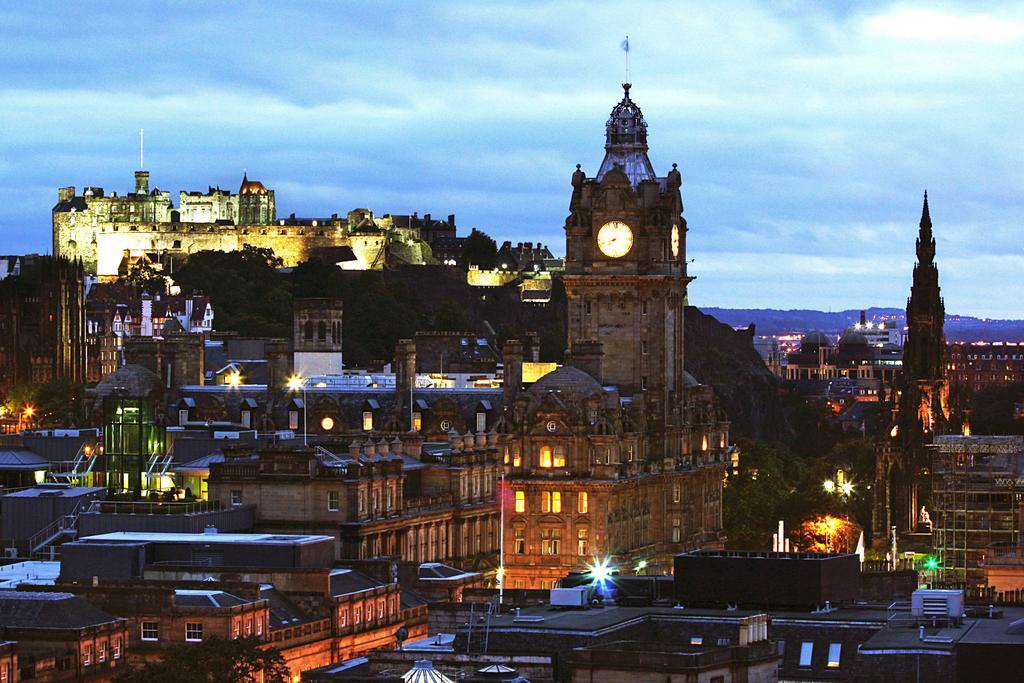What type of structures can be seen in the image? There are many buildings in the image. Is there any specific building with a distinct feature? Yes, there is a tower with a clock in the image. What is visible in the background of the image? There is a mountain in the backdrop of the image. How is the mountain covered? The mountain is covered with trees. What is the condition of the sky in the image? The sky is clear in the image. What year is the sister's birthday being celebrated in the image? There is no mention of a sister or a birthday celebration in the image. 